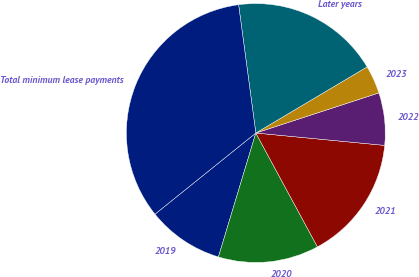Convert chart to OTSL. <chart><loc_0><loc_0><loc_500><loc_500><pie_chart><fcel>2019<fcel>2020<fcel>2021<fcel>2022<fcel>2023<fcel>Later years<fcel>Total minimum lease payments<nl><fcel>9.55%<fcel>12.56%<fcel>15.58%<fcel>6.54%<fcel>3.52%<fcel>18.59%<fcel>33.66%<nl></chart> 